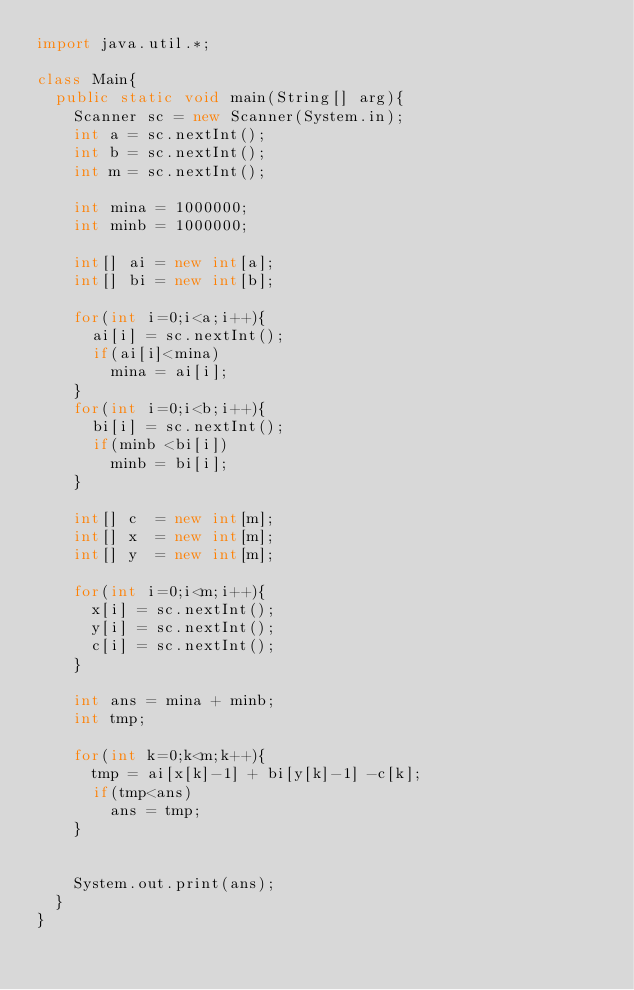Convert code to text. <code><loc_0><loc_0><loc_500><loc_500><_Java_>import java.util.*;

class Main{
  public static void main(String[] arg){
    Scanner sc = new Scanner(System.in);
    int a = sc.nextInt();
    int b = sc.nextInt();
    int m = sc.nextInt();
    
    int mina = 1000000;
    int minb = 1000000;
    
    int[] ai = new int[a];
    int[] bi = new int[b];
    
    for(int i=0;i<a;i++){
      ai[i] = sc.nextInt();
      if(ai[i]<mina)
        mina = ai[i];
    }
    for(int i=0;i<b;i++){
      bi[i] = sc.nextInt();
      if(minb <bi[i])
        minb = bi[i];
    }
    
    int[] c  = new int[m];
    int[] x  = new int[m];
    int[] y  = new int[m];
    
    for(int i=0;i<m;i++){
      x[i] = sc.nextInt();
      y[i] = sc.nextInt();
      c[i] = sc.nextInt();
    }
    
    int ans = mina + minb;
    int tmp;
    
    for(int k=0;k<m;k++){
      tmp = ai[x[k]-1] + bi[y[k]-1] -c[k];
      if(tmp<ans)
        ans = tmp;
    }
    
    
    System.out.print(ans);
  }
}</code> 